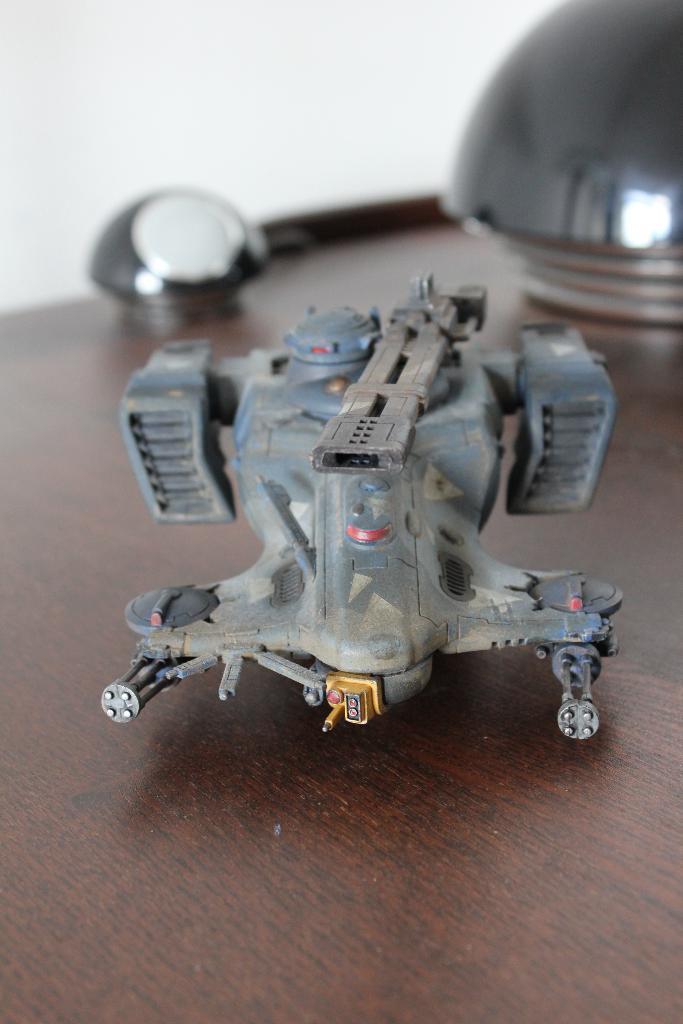Can you describe this image briefly? In the center of the image there is a toy placed on the table. In the background we can see some objects and wall. 